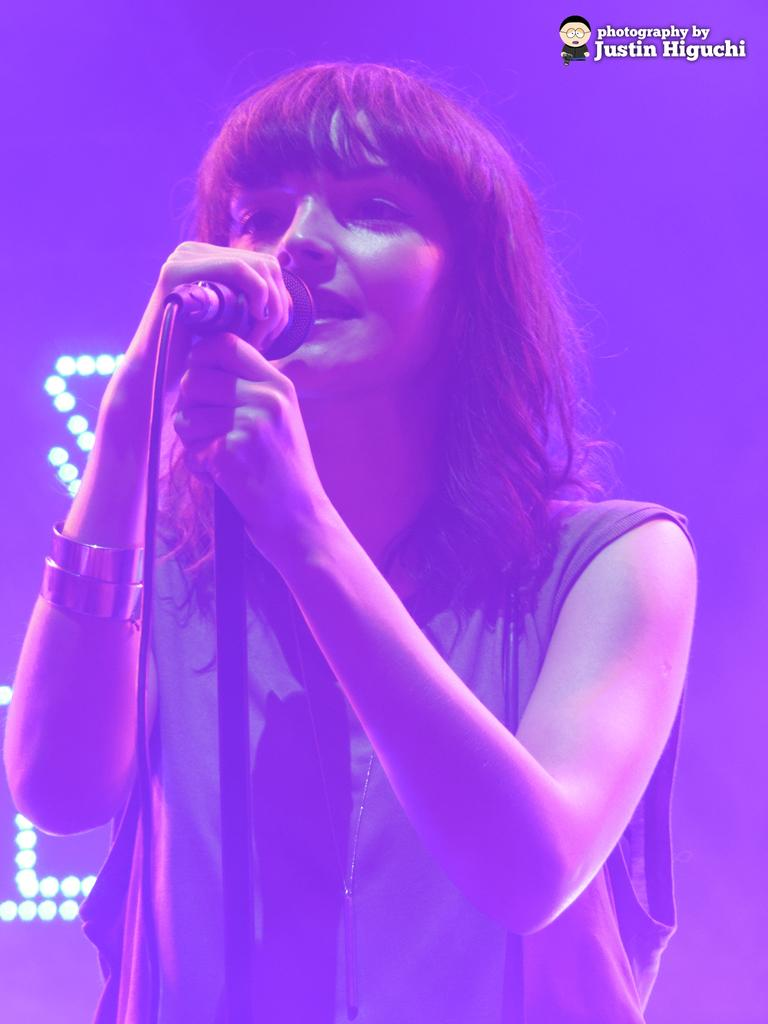Who is the main subject in the image? There is a woman in the image. What is the woman doing in the image? The woman is standing and singing. What object is the woman holding in the image? The woman is holding a microphone in the image. What type of flowers can be seen growing around the woman in the image? There are no flowers present in the image; it features a woman holding a microphone and singing. 